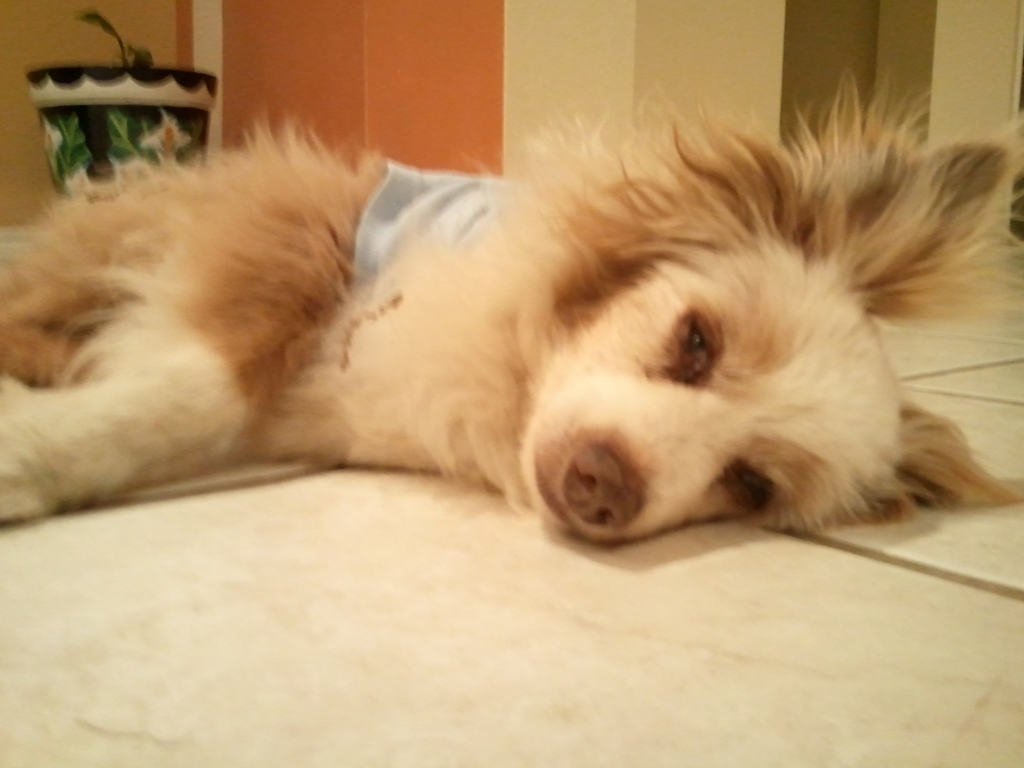Why is the picture considered acceptable? Based on my evaluation of the image's content and its composition, the picture can be considered satisfactory despite some blurriness due to the subject's appeal and the overall warm tone that contributes to a gentle aesthetic. The focal point, a dog wearing a light blue garment, has a softness that matches the mood conveyed by the scene, making the quality acceptable in a more artistic or emotive context. 